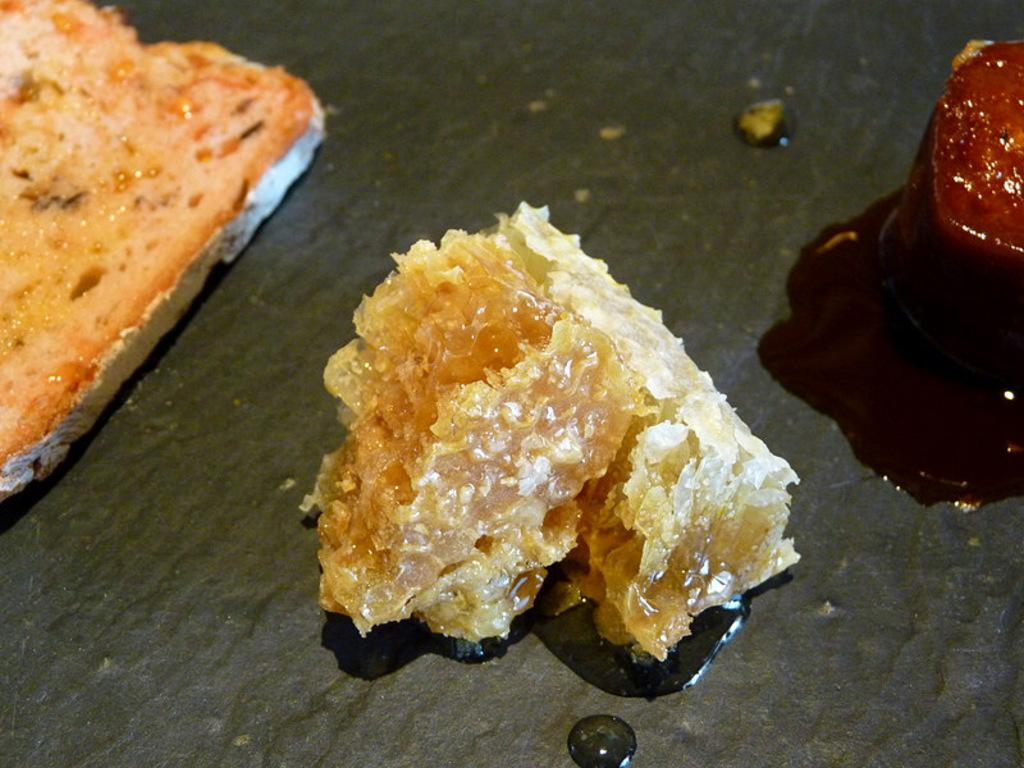What is present on the table in the image? There are food items on the table in the image. Is there any rain visible in the image? No, there is no rain visible in the image. What type of brake is present on the table in the image? There is no brake present on the table in the image. 